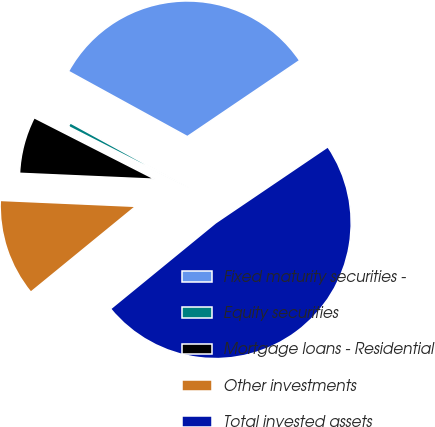Convert chart to OTSL. <chart><loc_0><loc_0><loc_500><loc_500><pie_chart><fcel>Fixed maturity securities -<fcel>Equity securities<fcel>Mortgage loans - Residential<fcel>Other investments<fcel>Total invested assets<nl><fcel>32.54%<fcel>0.49%<fcel>6.8%<fcel>11.61%<fcel>48.57%<nl></chart> 